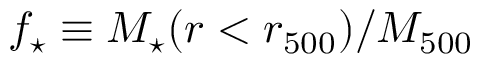<formula> <loc_0><loc_0><loc_500><loc_500>f _ { ^ { * } } \equiv M _ { ^ { * } } ( r < r _ { 5 0 0 } ) / M _ { 5 0 0 }</formula> 